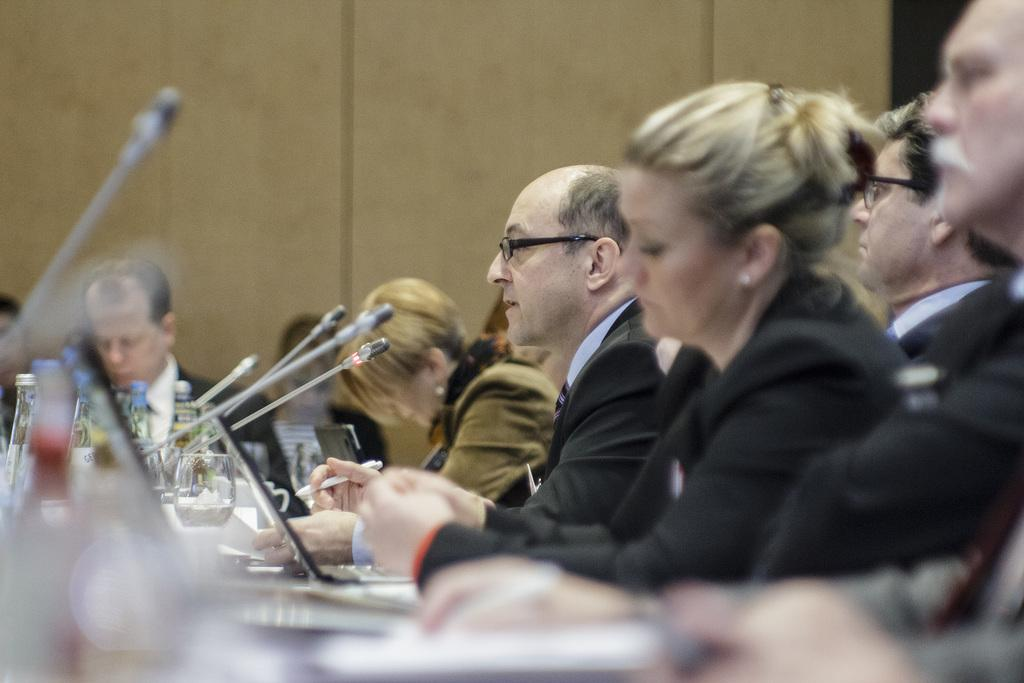What can be seen on the right side of the image? There is a group of people on the right side of the image. What are the people wearing? The people are wearing black coats. What is located on the left side of the image? There are microphones on the left side of the image. What device is in the middle of the image? There is a laptop in the middle of the image. Can you tell me how many dogs are present in the image? There are no dogs present in the image. What type of wrench is being used by the person in the image? There is no wrench present in the image. 